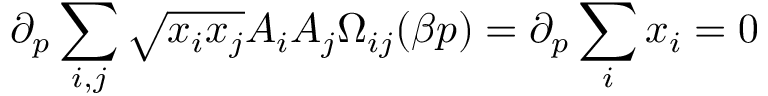Convert formula to latex. <formula><loc_0><loc_0><loc_500><loc_500>\partial _ { p } \sum _ { i , j } \sqrt { x _ { i } x _ { j } } A _ { i } A _ { j } \Omega _ { i j } ( \beta p ) = \partial _ { p } \sum _ { i } x _ { i } = 0</formula> 